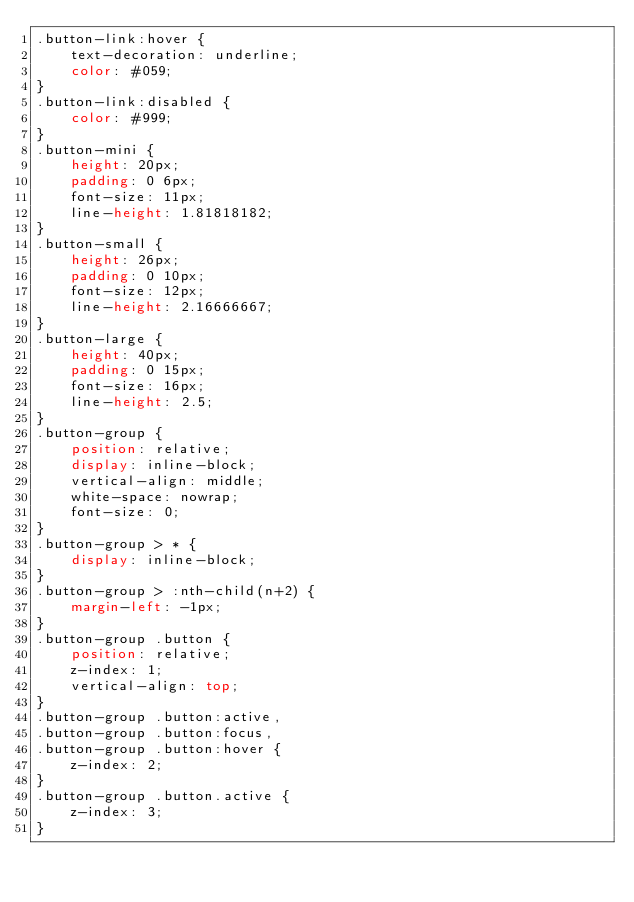<code> <loc_0><loc_0><loc_500><loc_500><_CSS_>.button-link:hover {
	text-decoration: underline;
	color: #059;
}
.button-link:disabled {
	color: #999;
}
.button-mini {
	height: 20px;
	padding: 0 6px;
	font-size: 11px;
	line-height: 1.81818182;
}
.button-small {
	height: 26px;
	padding: 0 10px;
	font-size: 12px;
	line-height: 2.16666667;
}
.button-large {
	height: 40px;
	padding: 0 15px;
	font-size: 16px;
	line-height: 2.5;
}
.button-group {
	position: relative;
	display: inline-block;
	vertical-align: middle;
	white-space: nowrap;
	font-size: 0;
}
.button-group > * {
	display: inline-block;
}
.button-group > :nth-child(n+2) {
	margin-left: -1px;
}
.button-group .button {
	position: relative;
	z-index: 1;
	vertical-align: top;
}
.button-group .button:active,
.button-group .button:focus,
.button-group .button:hover {
	z-index: 2;
}
.button-group .button.active {
	z-index: 3;
}
</code> 